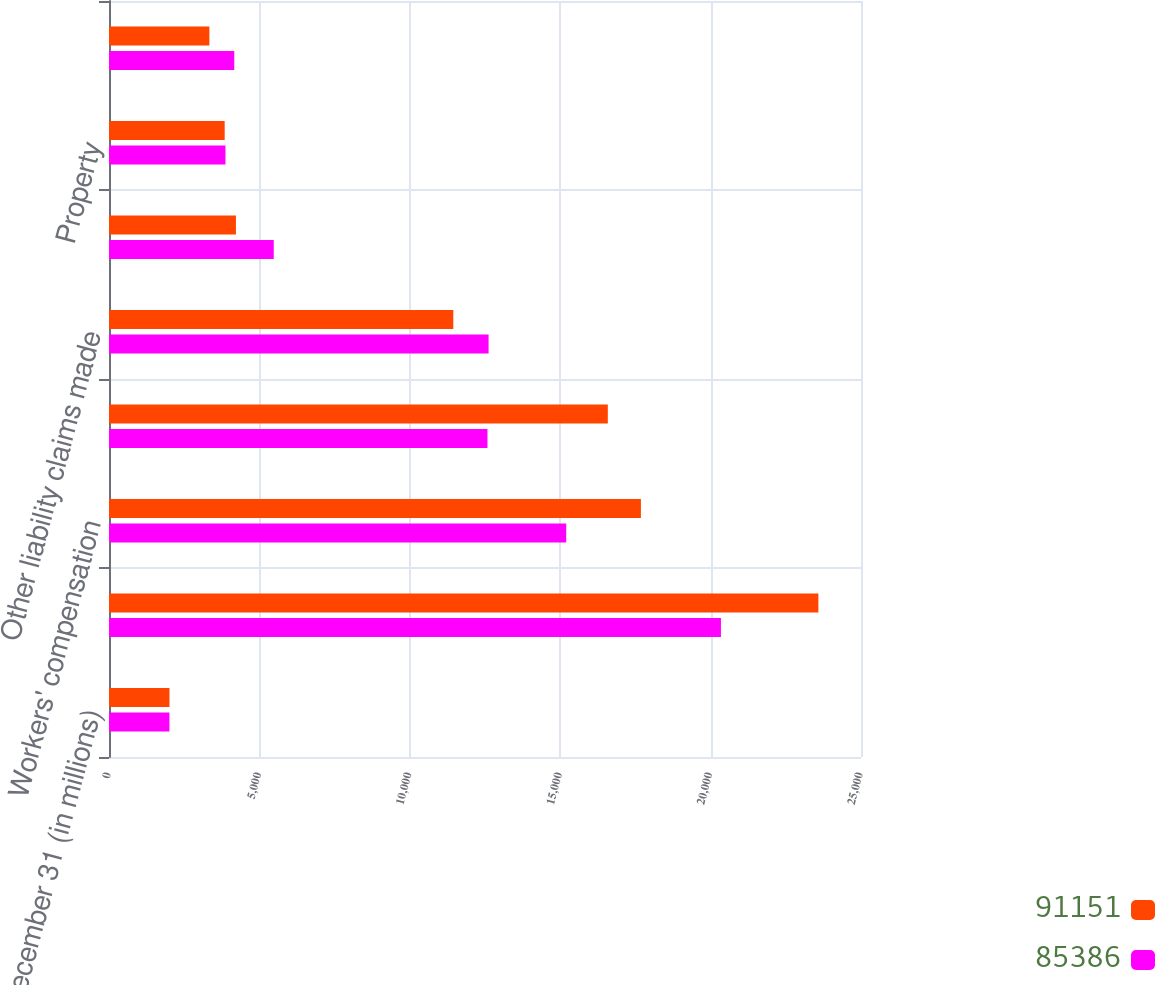Convert chart. <chart><loc_0><loc_0><loc_500><loc_500><stacked_bar_chart><ecel><fcel>At December 31 (in millions)<fcel>Other liability occurrence<fcel>Workers' compensation<fcel>International (b)<fcel>Other liability claims made<fcel>Mortgage Guaranty/Credit<fcel>Property<fcel>Auto liability<nl><fcel>91151<fcel>2010<fcel>23583<fcel>17683<fcel>16583<fcel>11446<fcel>4220<fcel>3846<fcel>3337<nl><fcel>85386<fcel>2009<fcel>20344<fcel>15200<fcel>12582<fcel>12619<fcel>5477<fcel>3872<fcel>4164<nl></chart> 